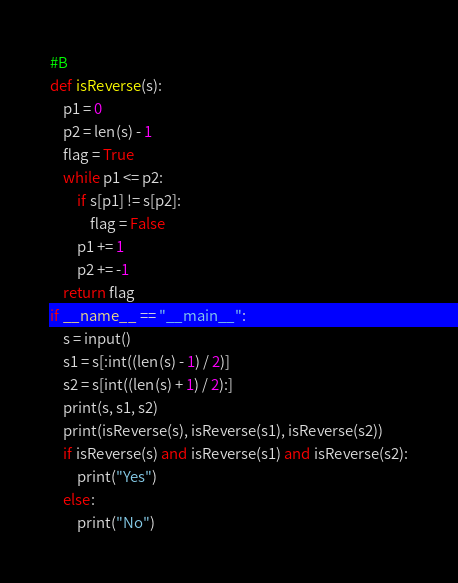<code> <loc_0><loc_0><loc_500><loc_500><_Python_>#B
def isReverse(s):
    p1 = 0
    p2 = len(s) - 1
    flag = True
    while p1 <= p2:
        if s[p1] != s[p2]:
            flag = False
        p1 += 1
        p2 += -1
    return flag
if __name__ == "__main__":
    s = input()
    s1 = s[:int((len(s) - 1) / 2)]
    s2 = s[int((len(s) + 1) / 2):]
    print(s, s1, s2)
    print(isReverse(s), isReverse(s1), isReverse(s2))
    if isReverse(s) and isReverse(s1) and isReverse(s2):
        print("Yes")
    else:
        print("No")</code> 